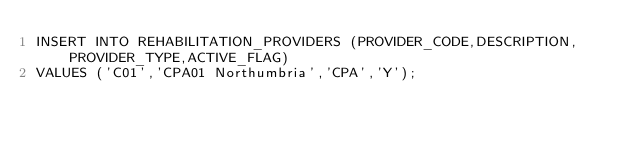Convert code to text. <code><loc_0><loc_0><loc_500><loc_500><_SQL_>INSERT INTO REHABILITATION_PROVIDERS (PROVIDER_CODE,DESCRIPTION,PROVIDER_TYPE,ACTIVE_FLAG)
VALUES ('C01','CPA01 Northumbria','CPA','Y');
</code> 